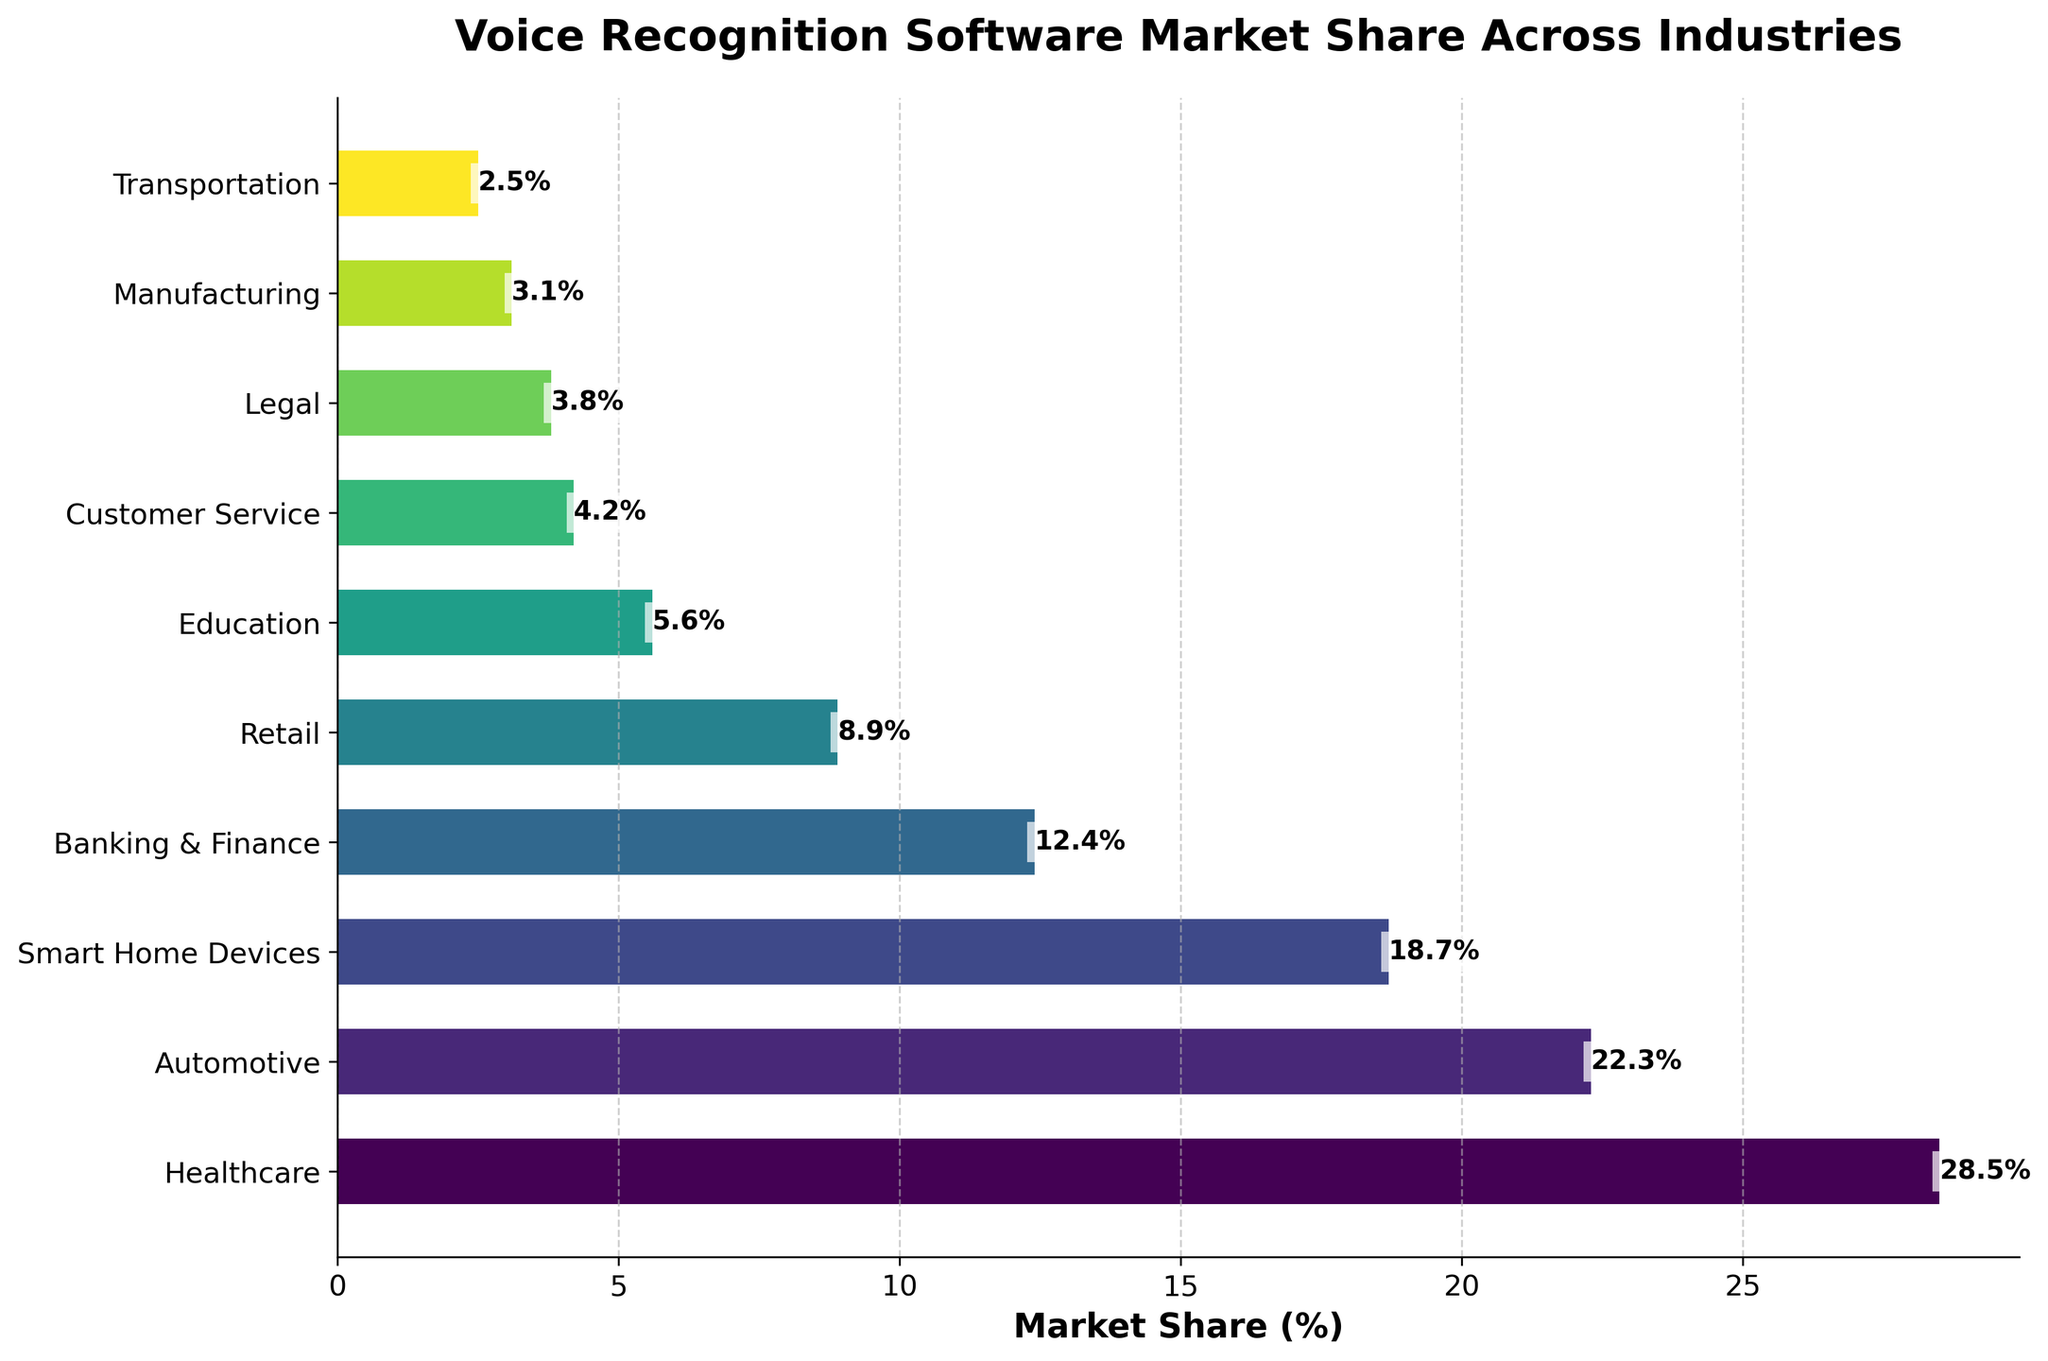What's the industry with the highest market share in voice recognition software? The highest bar in the horizontal bar chart represents the industry with the highest market share. Looking at the chart, Healthcare has the highest bar, indicating it has the largest market share.
Answer: Healthcare Which industry has the second-largest market share after Healthcare? The bar next to the highest one represents the second-largest market share. The second-highest bar corresponds to the Automotive industry.
Answer: Automotive What is the combined market share of Smart Home Devices and Retail? Looking at the values for Smart Home Devices (18.7%) and Retail (8.9%), sum them up to get the combined market share: 18.7% + 8.9% = 27.6%.
Answer: 27.6% Is the market share of Banking & Finance greater than or less than that of Automotive? Comparing the lengths of the bars, we see that the bar for Automotive (22.3%) is longer than that for Banking & Finance (12.4%). Hence, the market share of Banking & Finance is less than that of Automotive.
Answer: Less than What are the industries with a market share below 5%? By examining the bar lengths and their corresponding labels, we find that Customer Service (4.2%), Legal (3.8%), Manufacturing (3.1%), and Transportation (2.5%) each have market shares below 5%.
Answer: Customer Service, Legal, Manufacturing, Transportation How much more market share does Healthcare have than Education? Healthcare has a market share of 28.5%, and Education has 5.6%. Subtracting the two gives the difference: 28.5% - 5.6% = 22.9%.
Answer: 22.9% What's the average market share of the top three industries? The top three industries are Healthcare (28.5%), Automotive (22.3%), and Smart Home Devices (18.7%). The average is calculated as (28.5 + 22.3 + 18.7) / 3 = 69.5 / 3 = 23.17%.
Answer: 23.17% Which industry has the smallest market share, and what's its value? The shortest bar corresponds to the industry with the smallest market share. Here, Transportation has the shortest bar with a value of 2.5%.
Answer: Transportation, 2.5% What is the combined market share of industries that collectively exceed 50%? Healthcare (28.5%) and Automotive (22.3%) together exceed 50%. Summing these values: 28.5% + 22.3% = 50.8%.
Answer: 50.8% Are there more industries with a market share above 10% or below 10%? Counting the bars, we see four industries above 10% (Healthcare, Automotive, Smart Home Devices, Banking & Finance) and six industries below 10% (Retail, Education, Customer Service, Legal, Manufacturing, Transportation).
Answer: Below 10% 